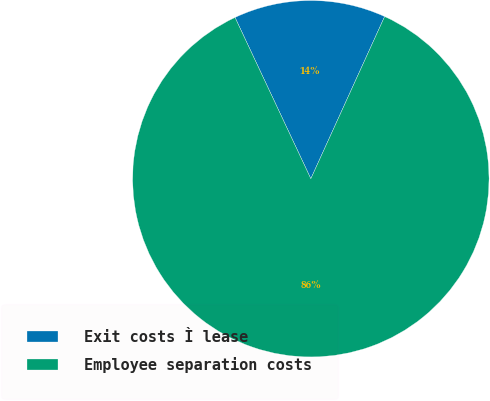Convert chart to OTSL. <chart><loc_0><loc_0><loc_500><loc_500><pie_chart><fcel>Exit costs Ì lease<fcel>Employee separation costs<nl><fcel>13.79%<fcel>86.21%<nl></chart> 